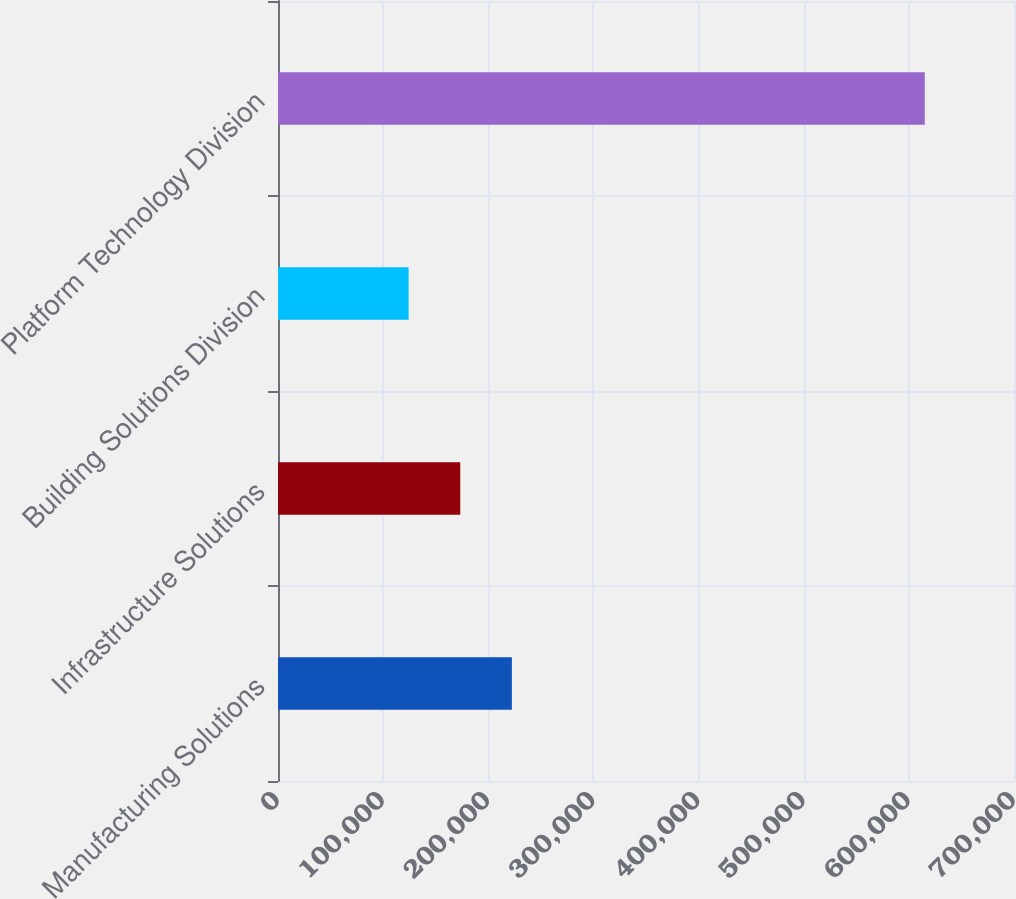<chart> <loc_0><loc_0><loc_500><loc_500><bar_chart><fcel>Manufacturing Solutions<fcel>Infrastructure Solutions<fcel>Building Solutions Division<fcel>Platform Technology Division<nl><fcel>222420<fcel>173330<fcel>124240<fcel>615140<nl></chart> 